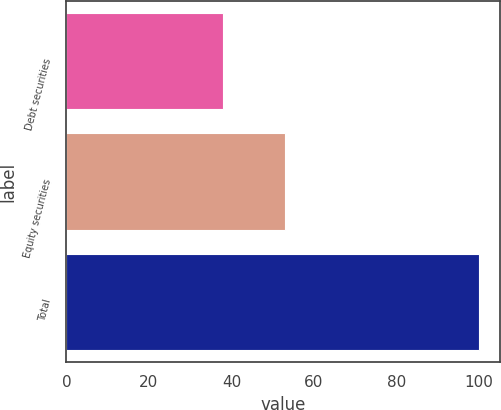<chart> <loc_0><loc_0><loc_500><loc_500><bar_chart><fcel>Debt securities<fcel>Equity securities<fcel>Total<nl><fcel>38<fcel>53<fcel>100<nl></chart> 